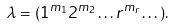<formula> <loc_0><loc_0><loc_500><loc_500>\lambda = ( 1 ^ { m _ { 1 } } 2 ^ { m _ { 2 } } \dots r ^ { m _ { r } } \dots ) .</formula> 